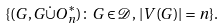<formula> <loc_0><loc_0><loc_500><loc_500>\{ ( G , G \dot { \cup } O _ { n } ^ { * } ) \colon G \in \mathcal { D } , \, | V ( G ) | = n \} .</formula> 